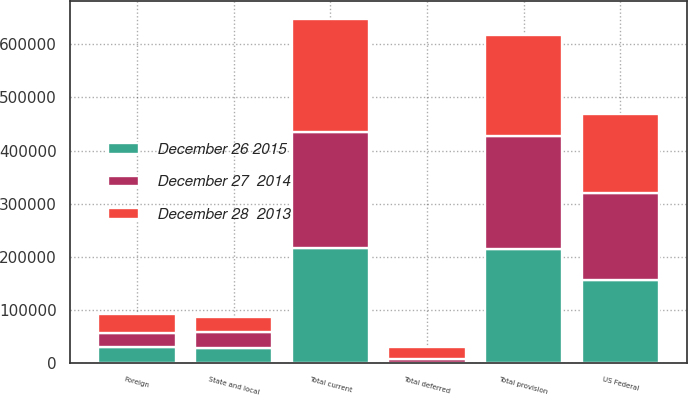Convert chart. <chart><loc_0><loc_0><loc_500><loc_500><stacked_bar_chart><ecel><fcel>US Federal<fcel>State and local<fcel>Foreign<fcel>Total current<fcel>Total deferred<fcel>Total provision<nl><fcel>December 27  2014<fcel>162948<fcel>29580<fcel>25104<fcel>217632<fcel>6241<fcel>211391<nl><fcel>December 26 2015<fcel>156956<fcel>28708<fcel>31038<fcel>216702<fcel>1092<fcel>215610<nl><fcel>December 28  2013<fcel>149336<fcel>28712<fcel>35880<fcel>213928<fcel>23037<fcel>190891<nl></chart> 